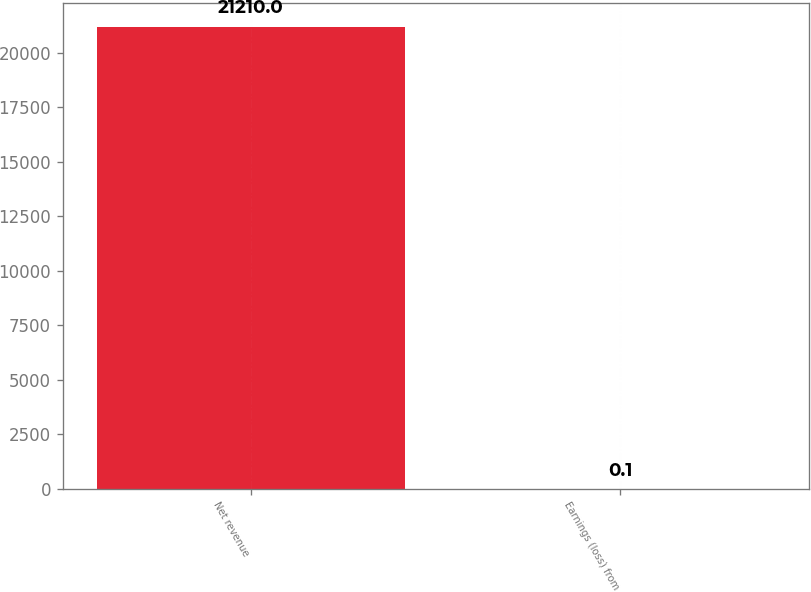Convert chart to OTSL. <chart><loc_0><loc_0><loc_500><loc_500><bar_chart><fcel>Net revenue<fcel>Earnings (loss) from<nl><fcel>21210<fcel>0.1<nl></chart> 